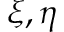<formula> <loc_0><loc_0><loc_500><loc_500>\xi , \eta</formula> 